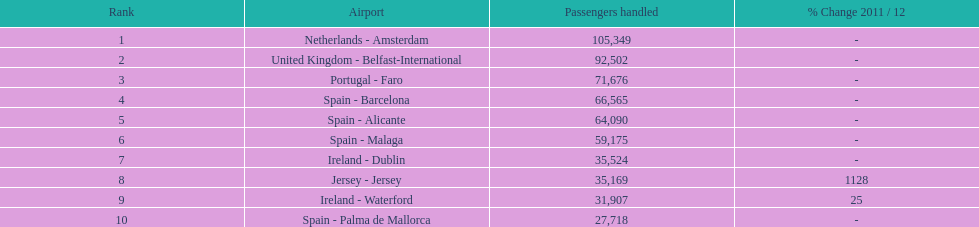Which airport has the least amount of passengers going through london southend airport? Spain - Palma de Mallorca. 